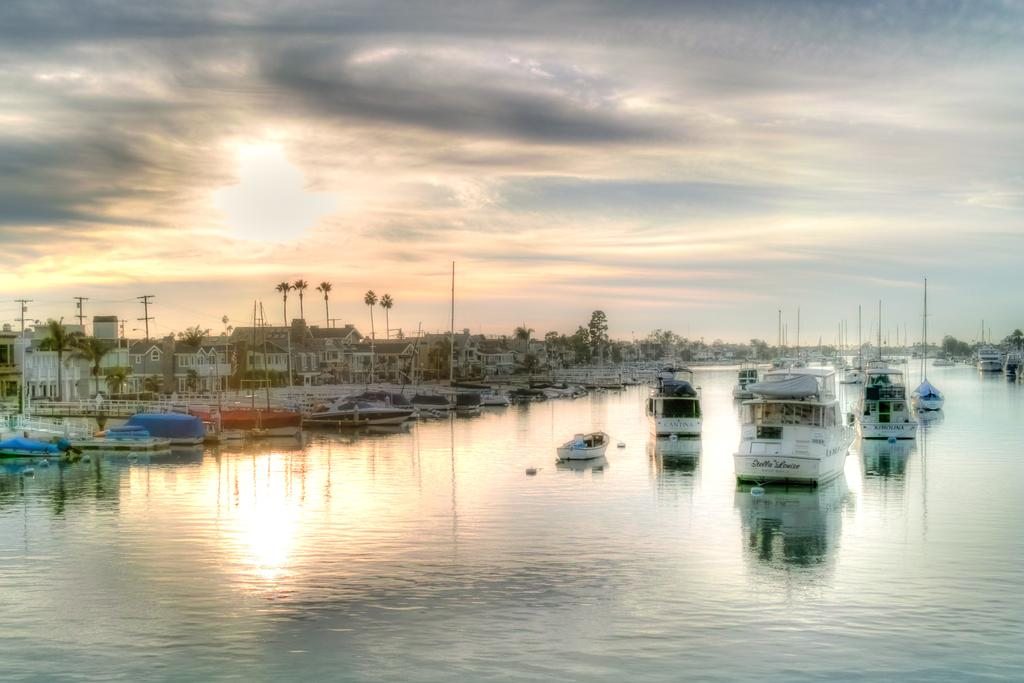What is the main subject in the center of the image? There are ships in the water in the center of the image. What can be seen in the background of the image? There are trees, buildings, current poles, and the sky visible in the background of the image. What type of card is being used to control the cannon in the image? There is no card or cannon present in the image. How many bits of information can be seen being transmitted between the ships in the image? There is no indication of any data transmission or bits in the image; it features ships in the water and various background elements. 